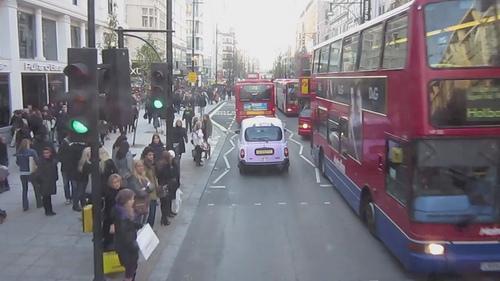How many levels does the bus have?
Give a very brief answer. 2. How many pink cars are pictured?
Give a very brief answer. 1. How many buses are pictured?
Give a very brief answer. 3. How many white vehicles are there?
Give a very brief answer. 1. 